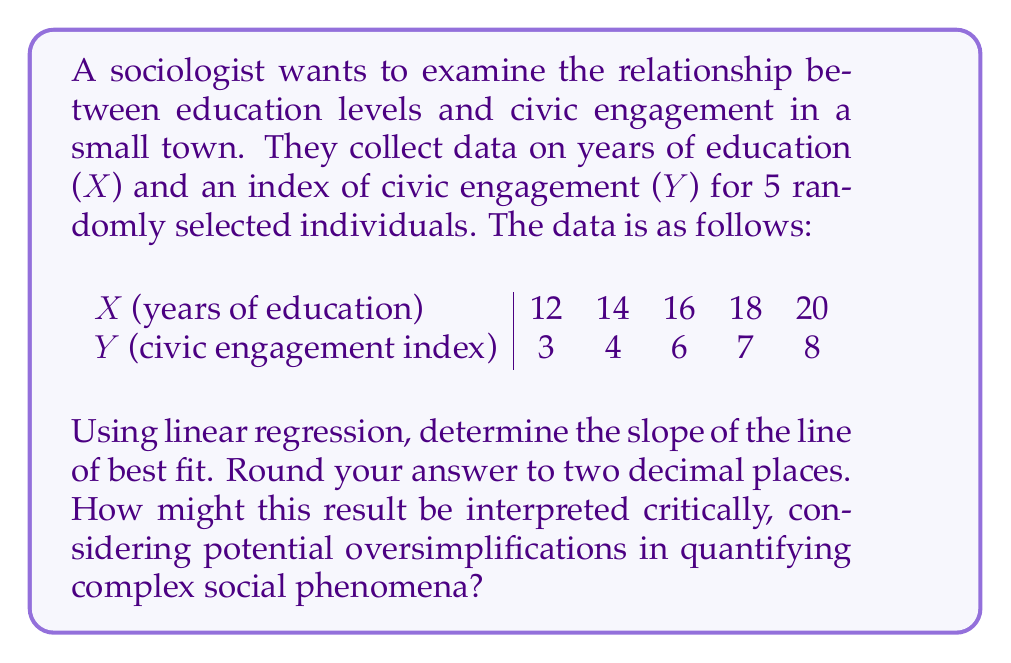Teach me how to tackle this problem. Let's approach this step-by-step:

1) For linear regression, we use the formula:

   $$b = \frac{n\sum xy - \sum x \sum y}{n\sum x^2 - (\sum x)^2}$$

   where $b$ is the slope, $n$ is the number of data points, $x$ are the independent variables (education years), and $y$ are the dependent variables (civic engagement index).

2) First, let's calculate the necessary sums:

   $n = 5$
   $\sum x = 12 + 14 + 16 + 18 + 20 = 80$
   $\sum y = 3 + 4 + 6 + 7 + 8 = 28$
   $\sum xy = (12 \times 3) + (14 \times 4) + (16 \times 6) + (18 \times 7) + (20 \times 8) = 470$
   $\sum x^2 = 12^2 + 14^2 + 16^2 + 18^2 + 20^2 = 1320$

3) Now, let's substitute these values into our formula:

   $$b = \frac{5(470) - (80)(28)}{5(1320) - (80)^2}$$

4) Simplify:

   $$b = \frac{2350 - 2240}{6600 - 6400} = \frac{110}{200} = 0.55$$

5) Rounding to two decimal places, we get 0.55.

Interpretation: The slope of 0.55 suggests that for each additional year of education, the civic engagement index increases by 0.55 units on average. However, this simplistic quantification fails to capture the nuances of civic engagement, which may be influenced by numerous factors beyond formal education. It doesn't account for the quality of education, socioeconomic factors, personal motivations, or the diverse ways individuals might engage civically outside of traditional metrics. This reductionist approach risks oversimplifying complex social dynamics and potentially reinforcing existing biases in how we measure and value civic participation.
Answer: 0.55 